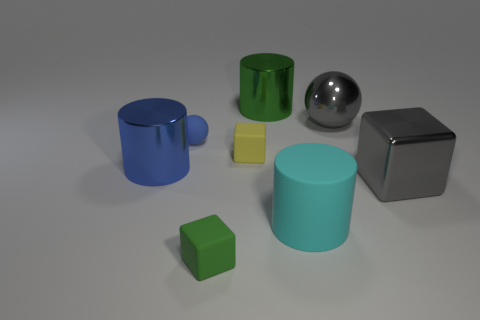What number of other objects are there of the same color as the metallic sphere?
Keep it short and to the point. 1. Is the material of the large cylinder on the left side of the green cylinder the same as the thing in front of the big matte object?
Offer a very short reply. No. Is the number of objects that are on the right side of the big matte object greater than the number of large gray metallic spheres behind the gray metal sphere?
Keep it short and to the point. Yes. The green object that is the same size as the cyan thing is what shape?
Make the answer very short. Cylinder. How many things are either yellow things or things behind the metal ball?
Give a very brief answer. 2. Is the color of the large shiny ball the same as the big cube?
Your response must be concise. Yes. There is a gray cube; how many rubber balls are in front of it?
Give a very brief answer. 0. There is a cube that is the same material as the green cylinder; what color is it?
Your answer should be compact. Gray. How many rubber objects are either large blue cylinders or balls?
Keep it short and to the point. 1. Does the big gray ball have the same material as the small blue object?
Provide a succinct answer. No. 